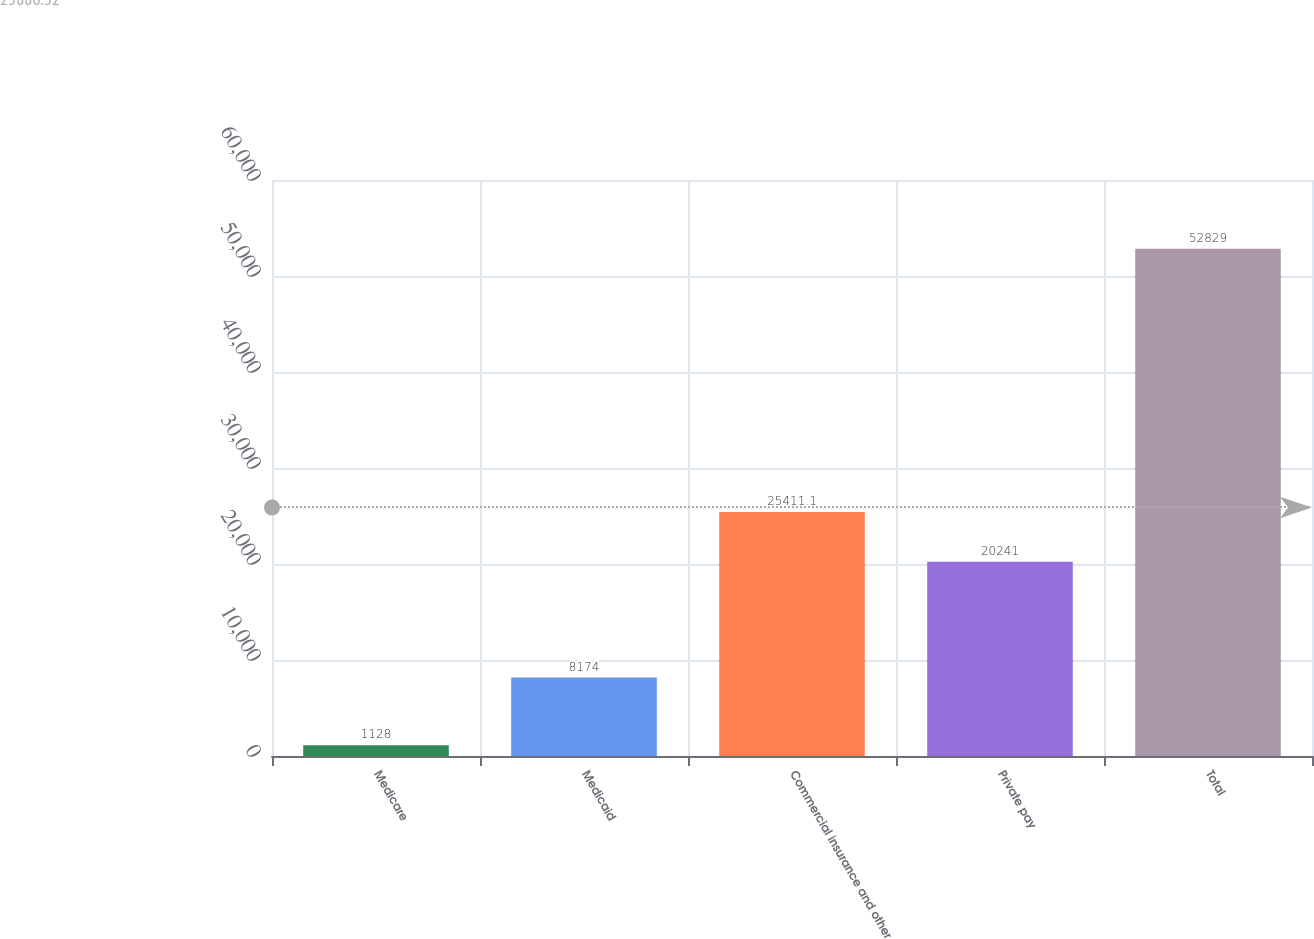Convert chart. <chart><loc_0><loc_0><loc_500><loc_500><bar_chart><fcel>Medicare<fcel>Medicaid<fcel>Commercial insurance and other<fcel>Private pay<fcel>Total<nl><fcel>1128<fcel>8174<fcel>25411.1<fcel>20241<fcel>52829<nl></chart> 